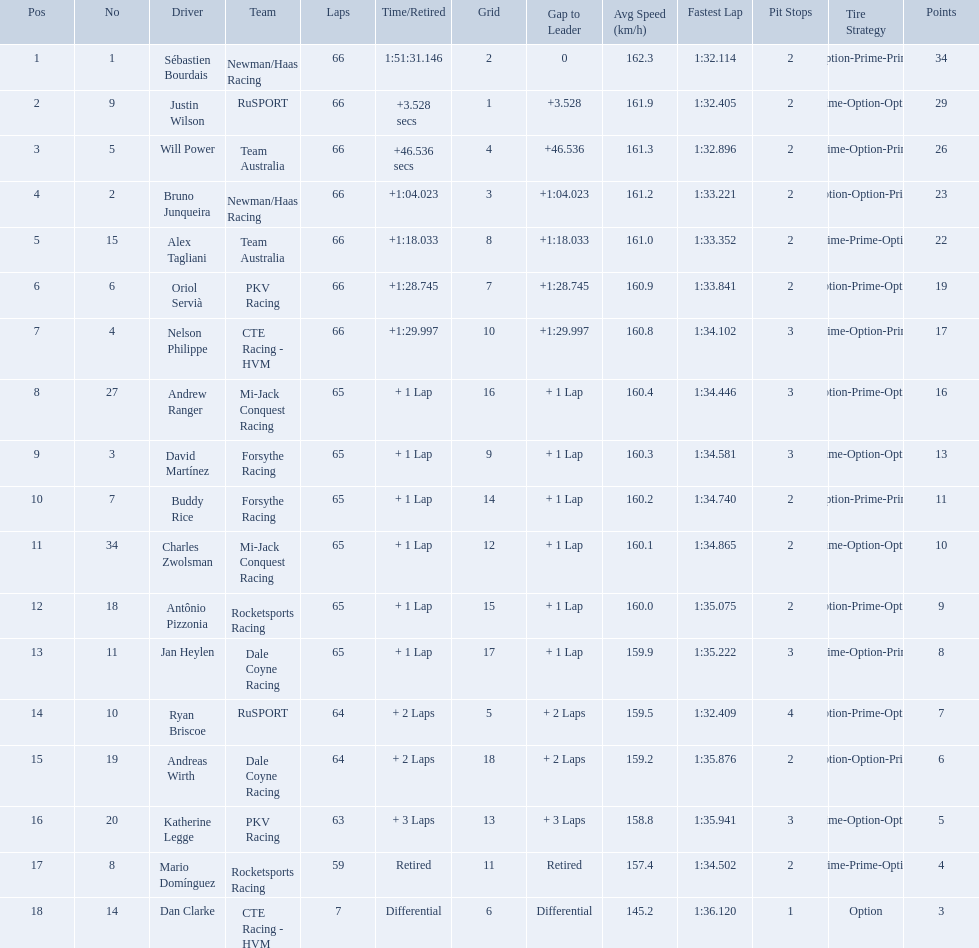How many laps did oriol servia complete at the 2006 gran premio? 66. How many laps did katherine legge complete at the 2006 gran premio? 63. Between servia and legge, who completed more laps? Oriol Servià. Which people scored 29+ points? Sébastien Bourdais, Justin Wilson. Who scored higher? Sébastien Bourdais. What are the drivers numbers? 1, 9, 5, 2, 15, 6, 4, 27, 3, 7, 34, 18, 11, 10, 19, 20, 8, 14. Are there any who's number matches his position? Sébastien Bourdais, Oriol Servià. Of those two who has the highest position? Sébastien Bourdais. 